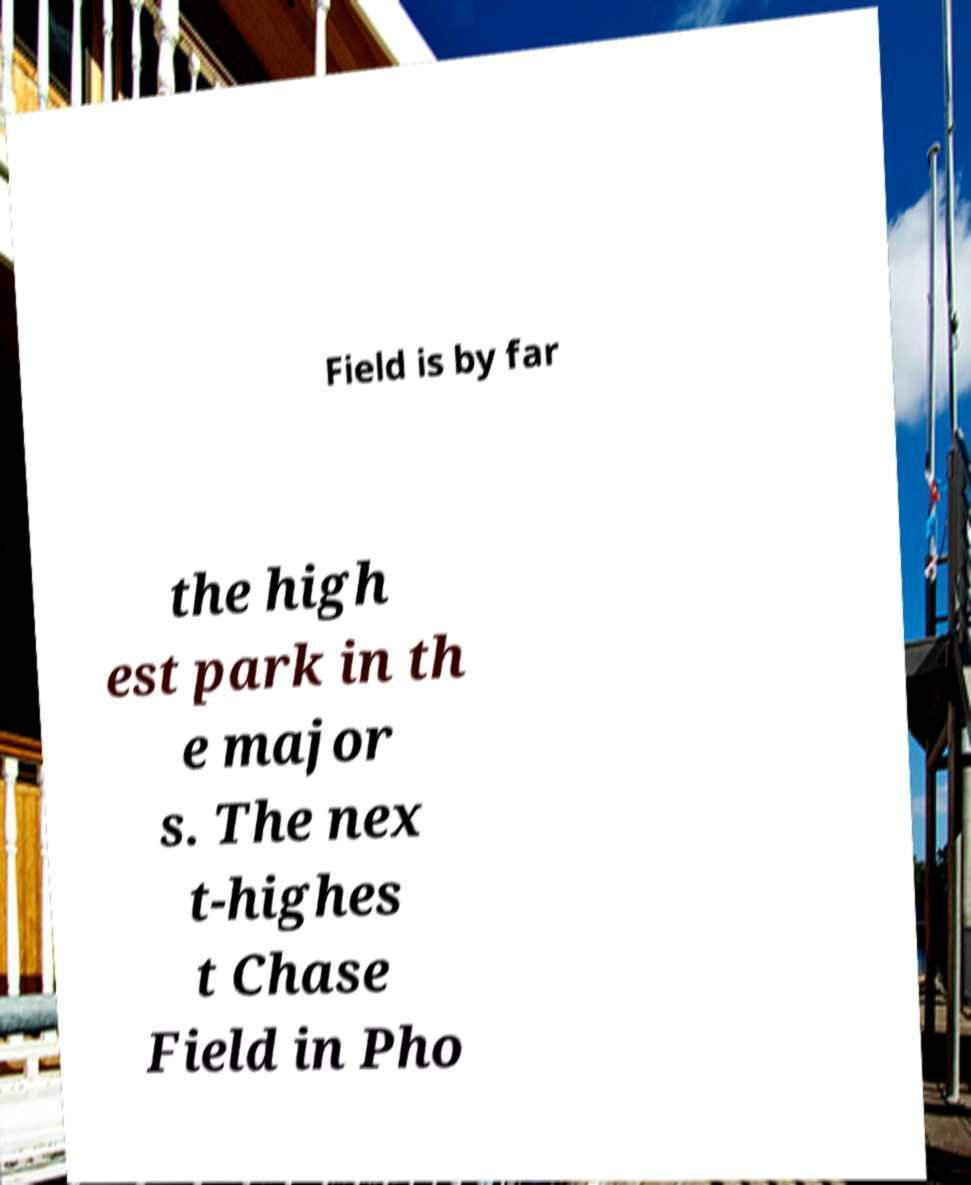Can you read and provide the text displayed in the image?This photo seems to have some interesting text. Can you extract and type it out for me? Field is by far the high est park in th e major s. The nex t-highes t Chase Field in Pho 